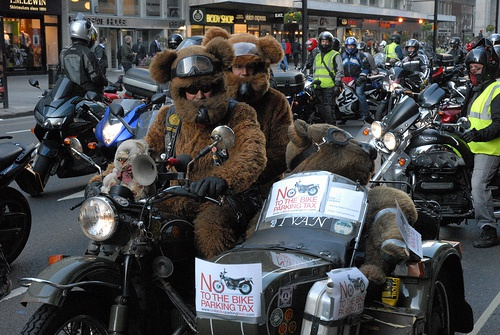Describe the objects in this image and their specific colors. I can see motorcycle in black, gray, darkgray, and darkblue tones, people in black, maroon, and gray tones, motorcycle in black, gray, white, and darkgray tones, teddy bear in black and gray tones, and people in black, maroon, and gray tones in this image. 